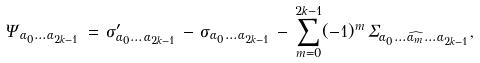<formula> <loc_0><loc_0><loc_500><loc_500>\Psi _ { \alpha _ { 0 } \dots \alpha _ { 2 k - 1 } } \, = \, \sigma ^ { \prime } _ { \alpha _ { 0 } \dots \alpha _ { 2 k - 1 } } \, - \, \sigma _ { \alpha _ { 0 } \dots \alpha _ { 2 k - 1 } } \, - \, \sum _ { m = 0 } ^ { 2 k - 1 } ( - 1 ) ^ { m } \, \Sigma _ { \alpha _ { 0 } \dots \widehat { \alpha _ { m } } \dots \alpha _ { 2 k - 1 } } ,</formula> 